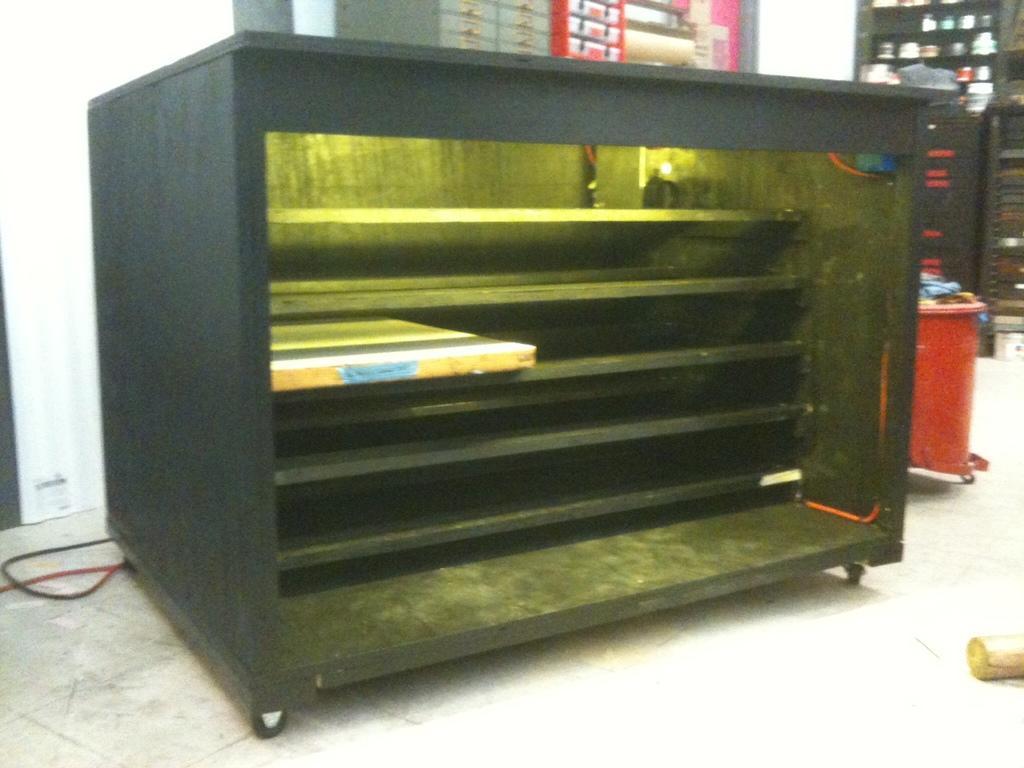Could you give a brief overview of what you see in this image? In this image in front there is a table with the rack and we can see a book on the rack. Beside the table there is a dustbin. On the backside there are cupboards with the items in it. Behind the cupboard there is a wall. 